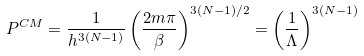Convert formula to latex. <formula><loc_0><loc_0><loc_500><loc_500>P ^ { C M } = \frac { 1 } { h ^ { 3 ( N - 1 ) } } \left ( \frac { 2 m \pi } { \beta } \right ) ^ { 3 ( N - 1 ) / 2 } = \left ( \frac { 1 } { \Lambda } \right ) ^ { 3 ( N - 1 ) }</formula> 